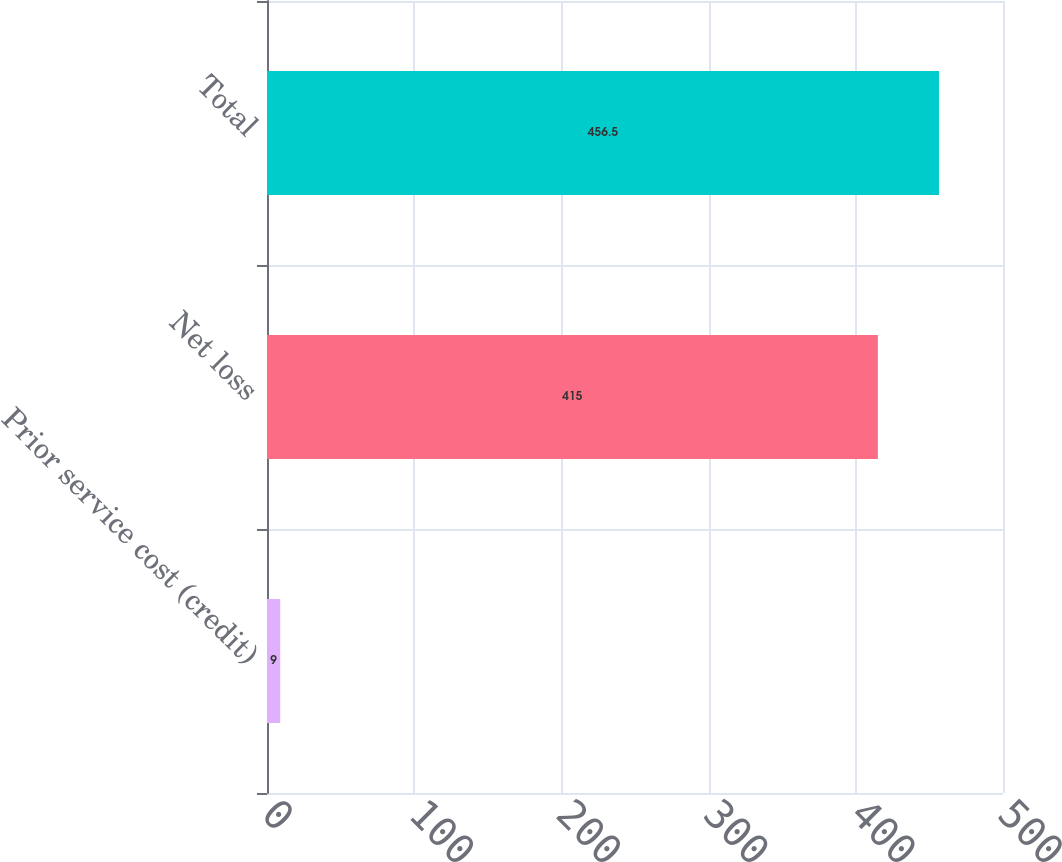Convert chart. <chart><loc_0><loc_0><loc_500><loc_500><bar_chart><fcel>Prior service cost (credit)<fcel>Net loss<fcel>Total<nl><fcel>9<fcel>415<fcel>456.5<nl></chart> 